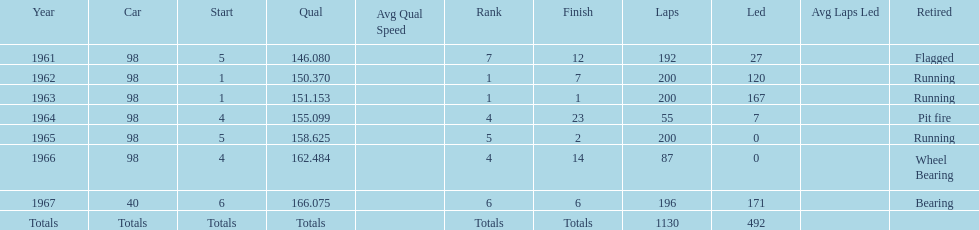How many consecutive years did parnelli place in the top 5? 5. 